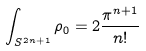Convert formula to latex. <formula><loc_0><loc_0><loc_500><loc_500>\int _ { S ^ { 2 n + 1 } } \rho _ { 0 } = 2 \frac { \pi ^ { n + 1 } } { n ! }</formula> 